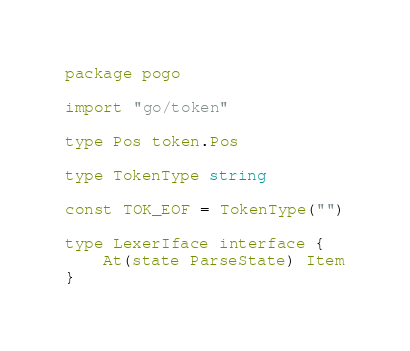Convert code to text. <code><loc_0><loc_0><loc_500><loc_500><_Go_>package pogo

import "go/token"

type Pos token.Pos

type TokenType string

const TOK_EOF = TokenType("")

type LexerIface interface {
	At(state ParseState) Item
}
</code> 